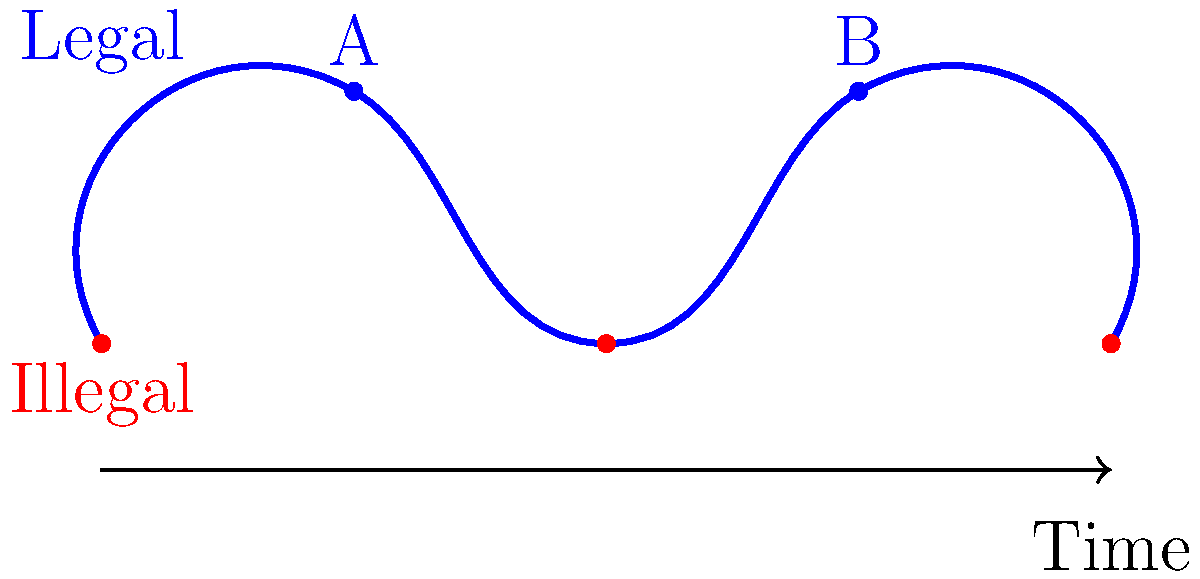Consider the Möbius strip representation of marriage equality laws over time shown above. If point A represents the current state where same-sex marriage is legal, and the strip completes one full twist before reaching point B, what does point B most likely represent in terms of marriage equality? To answer this question, we need to understand the properties of a Möbius strip and how it relates to the evolution of marriage equality laws:

1. A Möbius strip has only one side and one edge. If you trace a path along the surface, you'll eventually return to the starting point on the "opposite" side.

2. In this representation, the upper part of the strip represents states where same-sex marriage is legal, and the lower part represents states where it's illegal.

3. Point A represents the current state where same-sex marriage is legal.

4. The strip completes one full twist before reaching point B. This means that if we follow the path from A to B, we'll end up on the "opposite" side of where we started.

5. Since we started on the "legal" side at point A, after one full twist, we would end up on the "illegal" side.

6. However, point B is shown on the upper (legal) side of the strip.

7. This apparent contradiction suggests that between points A and B, there must have been a significant change in marriage equality laws that "flipped" the legal status back to the upper side.

8. In the context of marriage equality, this most likely represents a reinstatement of same-sex marriage rights after a period of regression.

Therefore, point B most likely represents a future state where same-sex marriage has been re-legalized after a period of being made illegal again.
Answer: Re-legalization of same-sex marriage 